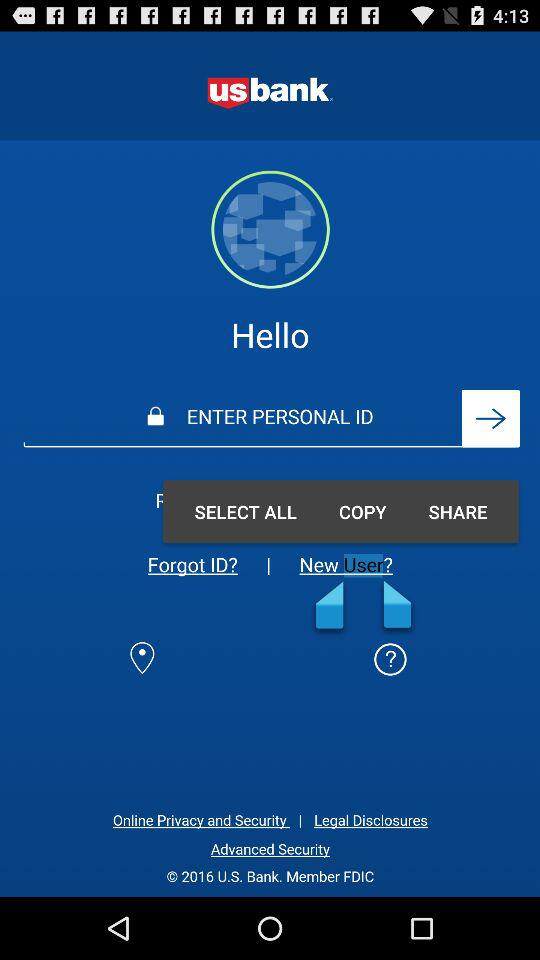What is the name of the application? The name of the application is "usbank". 